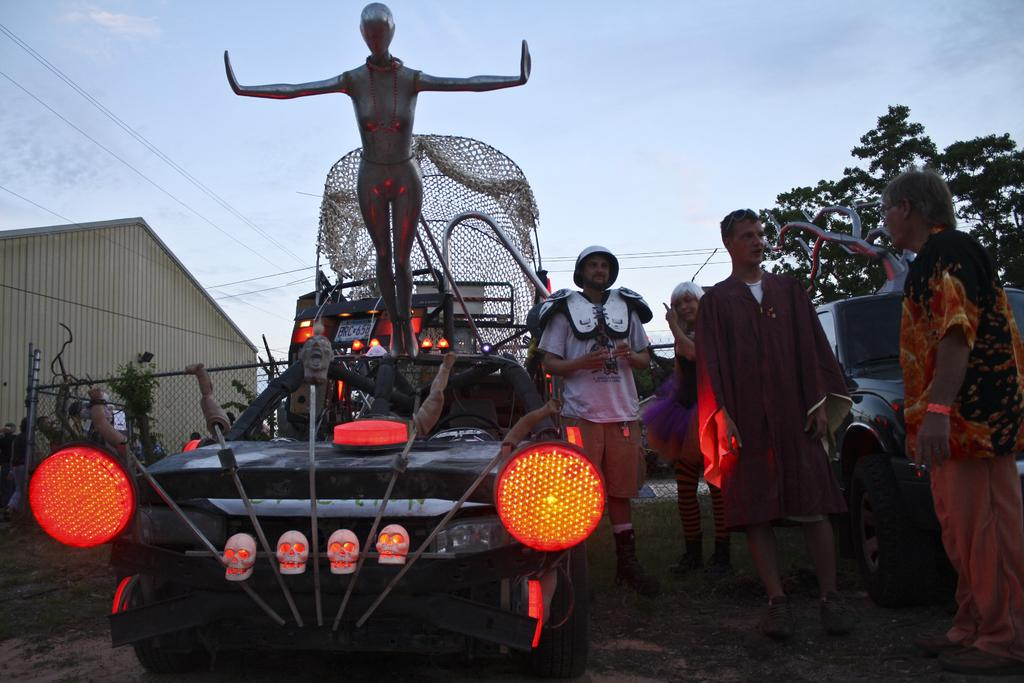What is the statue placed on in the image? The statue is placed on a vehicle in the image. What can be seen on the right side of the image? There are people standing on the right side of the image. What type of natural vegetation is visible in the image? There are trees visible in the image. What structure is located on the left side of the image? There is a shed on the left side of the image. What type of vehicle is visible at the top of the image? There is a car visible at the top of the image. What type of base is supporting the statue in the image? There is no mention of a base supporting the statue in the image; it is placed on a vehicle. What type of blade is being used by the people standing on the right side of the image? There is no mention of a blade or any tool being used by the people in the image. 